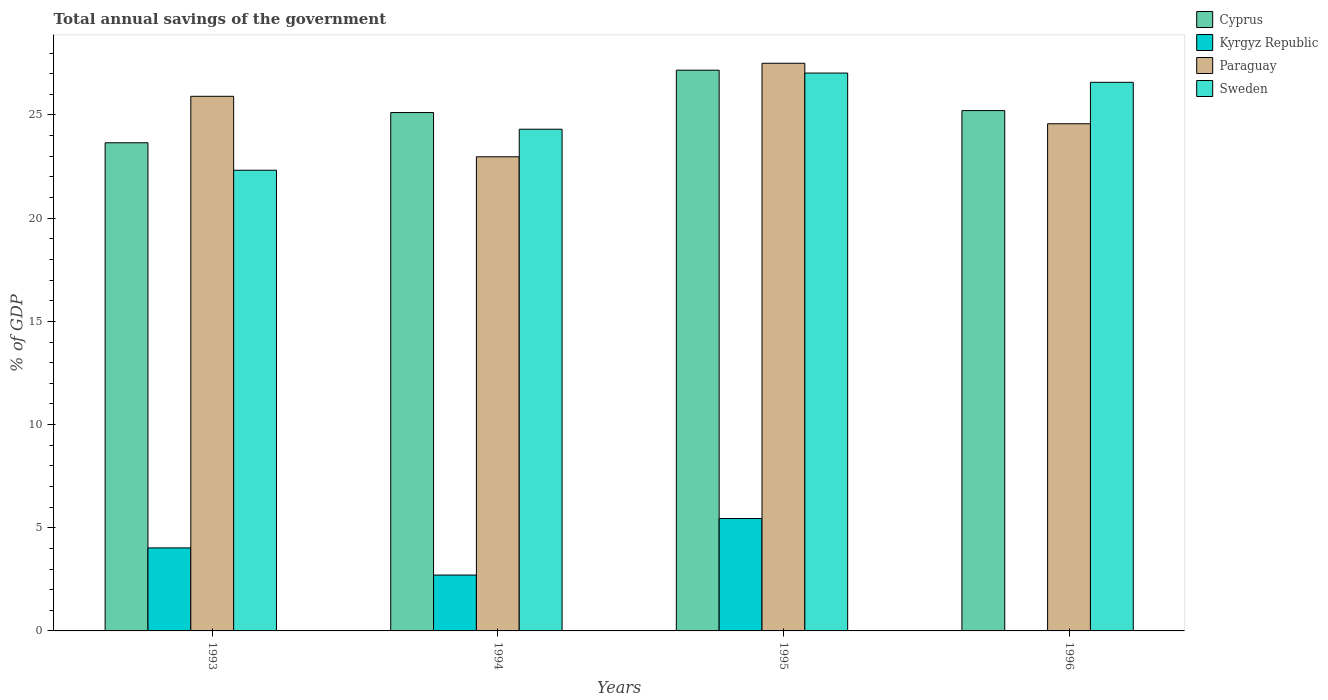How many groups of bars are there?
Provide a short and direct response. 4. Are the number of bars on each tick of the X-axis equal?
Ensure brevity in your answer.  No. In how many cases, is the number of bars for a given year not equal to the number of legend labels?
Your answer should be very brief. 1. What is the total annual savings of the government in Sweden in 1996?
Make the answer very short. 26.58. Across all years, what is the maximum total annual savings of the government in Sweden?
Your response must be concise. 27.03. Across all years, what is the minimum total annual savings of the government in Sweden?
Give a very brief answer. 22.32. In which year was the total annual savings of the government in Kyrgyz Republic maximum?
Provide a succinct answer. 1995. What is the total total annual savings of the government in Sweden in the graph?
Provide a succinct answer. 100.25. What is the difference between the total annual savings of the government in Paraguay in 1993 and that in 1995?
Provide a short and direct response. -1.6. What is the difference between the total annual savings of the government in Paraguay in 1996 and the total annual savings of the government in Sweden in 1994?
Keep it short and to the point. 0.26. What is the average total annual savings of the government in Sweden per year?
Provide a succinct answer. 25.06. In the year 1993, what is the difference between the total annual savings of the government in Kyrgyz Republic and total annual savings of the government in Sweden?
Your response must be concise. -18.3. In how many years, is the total annual savings of the government in Sweden greater than 14 %?
Ensure brevity in your answer.  4. What is the ratio of the total annual savings of the government in Sweden in 1994 to that in 1996?
Ensure brevity in your answer.  0.91. Is the total annual savings of the government in Kyrgyz Republic in 1993 less than that in 1994?
Provide a short and direct response. No. What is the difference between the highest and the second highest total annual savings of the government in Paraguay?
Your answer should be compact. 1.6. What is the difference between the highest and the lowest total annual savings of the government in Kyrgyz Republic?
Ensure brevity in your answer.  5.45. In how many years, is the total annual savings of the government in Cyprus greater than the average total annual savings of the government in Cyprus taken over all years?
Make the answer very short. 1. Is it the case that in every year, the sum of the total annual savings of the government in Paraguay and total annual savings of the government in Cyprus is greater than the sum of total annual savings of the government in Sweden and total annual savings of the government in Kyrgyz Republic?
Provide a short and direct response. No. Is it the case that in every year, the sum of the total annual savings of the government in Cyprus and total annual savings of the government in Paraguay is greater than the total annual savings of the government in Sweden?
Give a very brief answer. Yes. Are all the bars in the graph horizontal?
Offer a very short reply. No. What is the difference between two consecutive major ticks on the Y-axis?
Keep it short and to the point. 5. Does the graph contain any zero values?
Your answer should be very brief. Yes. Does the graph contain grids?
Provide a succinct answer. No. How many legend labels are there?
Give a very brief answer. 4. How are the legend labels stacked?
Ensure brevity in your answer.  Vertical. What is the title of the graph?
Give a very brief answer. Total annual savings of the government. Does "Portugal" appear as one of the legend labels in the graph?
Your answer should be very brief. No. What is the label or title of the X-axis?
Offer a terse response. Years. What is the label or title of the Y-axis?
Offer a very short reply. % of GDP. What is the % of GDP in Cyprus in 1993?
Your response must be concise. 23.65. What is the % of GDP in Kyrgyz Republic in 1993?
Your response must be concise. 4.02. What is the % of GDP in Paraguay in 1993?
Offer a terse response. 25.91. What is the % of GDP in Sweden in 1993?
Offer a terse response. 22.32. What is the % of GDP in Cyprus in 1994?
Your answer should be compact. 25.12. What is the % of GDP in Kyrgyz Republic in 1994?
Provide a short and direct response. 2.71. What is the % of GDP of Paraguay in 1994?
Provide a succinct answer. 22.97. What is the % of GDP in Sweden in 1994?
Offer a very short reply. 24.31. What is the % of GDP in Cyprus in 1995?
Give a very brief answer. 27.17. What is the % of GDP in Kyrgyz Republic in 1995?
Offer a terse response. 5.45. What is the % of GDP of Paraguay in 1995?
Keep it short and to the point. 27.51. What is the % of GDP in Sweden in 1995?
Your answer should be very brief. 27.03. What is the % of GDP in Cyprus in 1996?
Your answer should be very brief. 25.21. What is the % of GDP in Paraguay in 1996?
Provide a succinct answer. 24.58. What is the % of GDP in Sweden in 1996?
Your answer should be very brief. 26.58. Across all years, what is the maximum % of GDP in Cyprus?
Offer a terse response. 27.17. Across all years, what is the maximum % of GDP of Kyrgyz Republic?
Your answer should be compact. 5.45. Across all years, what is the maximum % of GDP of Paraguay?
Your answer should be compact. 27.51. Across all years, what is the maximum % of GDP of Sweden?
Provide a short and direct response. 27.03. Across all years, what is the minimum % of GDP of Cyprus?
Provide a short and direct response. 23.65. Across all years, what is the minimum % of GDP of Kyrgyz Republic?
Provide a short and direct response. 0. Across all years, what is the minimum % of GDP in Paraguay?
Keep it short and to the point. 22.97. Across all years, what is the minimum % of GDP of Sweden?
Give a very brief answer. 22.32. What is the total % of GDP of Cyprus in the graph?
Offer a terse response. 101.16. What is the total % of GDP of Kyrgyz Republic in the graph?
Ensure brevity in your answer.  12.18. What is the total % of GDP in Paraguay in the graph?
Offer a very short reply. 100.96. What is the total % of GDP of Sweden in the graph?
Your answer should be very brief. 100.25. What is the difference between the % of GDP of Cyprus in 1993 and that in 1994?
Provide a succinct answer. -1.46. What is the difference between the % of GDP in Kyrgyz Republic in 1993 and that in 1994?
Your response must be concise. 1.32. What is the difference between the % of GDP of Paraguay in 1993 and that in 1994?
Offer a very short reply. 2.93. What is the difference between the % of GDP of Sweden in 1993 and that in 1994?
Ensure brevity in your answer.  -1.99. What is the difference between the % of GDP of Cyprus in 1993 and that in 1995?
Give a very brief answer. -3.52. What is the difference between the % of GDP in Kyrgyz Republic in 1993 and that in 1995?
Give a very brief answer. -1.43. What is the difference between the % of GDP of Paraguay in 1993 and that in 1995?
Provide a short and direct response. -1.6. What is the difference between the % of GDP of Sweden in 1993 and that in 1995?
Offer a terse response. -4.71. What is the difference between the % of GDP of Cyprus in 1993 and that in 1996?
Your answer should be very brief. -1.56. What is the difference between the % of GDP of Paraguay in 1993 and that in 1996?
Your response must be concise. 1.33. What is the difference between the % of GDP of Sweden in 1993 and that in 1996?
Ensure brevity in your answer.  -4.26. What is the difference between the % of GDP of Cyprus in 1994 and that in 1995?
Provide a short and direct response. -2.05. What is the difference between the % of GDP in Kyrgyz Republic in 1994 and that in 1995?
Keep it short and to the point. -2.74. What is the difference between the % of GDP in Paraguay in 1994 and that in 1995?
Provide a short and direct response. -4.53. What is the difference between the % of GDP of Sweden in 1994 and that in 1995?
Provide a succinct answer. -2.72. What is the difference between the % of GDP of Cyprus in 1994 and that in 1996?
Provide a short and direct response. -0.09. What is the difference between the % of GDP of Paraguay in 1994 and that in 1996?
Keep it short and to the point. -1.6. What is the difference between the % of GDP of Sweden in 1994 and that in 1996?
Make the answer very short. -2.27. What is the difference between the % of GDP in Cyprus in 1995 and that in 1996?
Ensure brevity in your answer.  1.96. What is the difference between the % of GDP in Paraguay in 1995 and that in 1996?
Make the answer very short. 2.93. What is the difference between the % of GDP in Sweden in 1995 and that in 1996?
Your answer should be very brief. 0.45. What is the difference between the % of GDP in Cyprus in 1993 and the % of GDP in Kyrgyz Republic in 1994?
Offer a very short reply. 20.95. What is the difference between the % of GDP in Cyprus in 1993 and the % of GDP in Paraguay in 1994?
Your response must be concise. 0.68. What is the difference between the % of GDP of Cyprus in 1993 and the % of GDP of Sweden in 1994?
Give a very brief answer. -0.66. What is the difference between the % of GDP in Kyrgyz Republic in 1993 and the % of GDP in Paraguay in 1994?
Your response must be concise. -18.95. What is the difference between the % of GDP of Kyrgyz Republic in 1993 and the % of GDP of Sweden in 1994?
Ensure brevity in your answer.  -20.29. What is the difference between the % of GDP of Paraguay in 1993 and the % of GDP of Sweden in 1994?
Ensure brevity in your answer.  1.6. What is the difference between the % of GDP of Cyprus in 1993 and the % of GDP of Kyrgyz Republic in 1995?
Ensure brevity in your answer.  18.21. What is the difference between the % of GDP in Cyprus in 1993 and the % of GDP in Paraguay in 1995?
Keep it short and to the point. -3.85. What is the difference between the % of GDP in Cyprus in 1993 and the % of GDP in Sweden in 1995?
Offer a terse response. -3.38. What is the difference between the % of GDP of Kyrgyz Republic in 1993 and the % of GDP of Paraguay in 1995?
Ensure brevity in your answer.  -23.48. What is the difference between the % of GDP in Kyrgyz Republic in 1993 and the % of GDP in Sweden in 1995?
Make the answer very short. -23.01. What is the difference between the % of GDP in Paraguay in 1993 and the % of GDP in Sweden in 1995?
Give a very brief answer. -1.13. What is the difference between the % of GDP in Cyprus in 1993 and the % of GDP in Paraguay in 1996?
Offer a terse response. -0.92. What is the difference between the % of GDP in Cyprus in 1993 and the % of GDP in Sweden in 1996?
Provide a succinct answer. -2.93. What is the difference between the % of GDP of Kyrgyz Republic in 1993 and the % of GDP of Paraguay in 1996?
Offer a terse response. -20.55. What is the difference between the % of GDP in Kyrgyz Republic in 1993 and the % of GDP in Sweden in 1996?
Your answer should be compact. -22.56. What is the difference between the % of GDP of Paraguay in 1993 and the % of GDP of Sweden in 1996?
Your answer should be compact. -0.68. What is the difference between the % of GDP of Cyprus in 1994 and the % of GDP of Kyrgyz Republic in 1995?
Provide a short and direct response. 19.67. What is the difference between the % of GDP of Cyprus in 1994 and the % of GDP of Paraguay in 1995?
Ensure brevity in your answer.  -2.39. What is the difference between the % of GDP in Cyprus in 1994 and the % of GDP in Sweden in 1995?
Offer a very short reply. -1.91. What is the difference between the % of GDP in Kyrgyz Republic in 1994 and the % of GDP in Paraguay in 1995?
Ensure brevity in your answer.  -24.8. What is the difference between the % of GDP in Kyrgyz Republic in 1994 and the % of GDP in Sweden in 1995?
Offer a very short reply. -24.33. What is the difference between the % of GDP in Paraguay in 1994 and the % of GDP in Sweden in 1995?
Offer a very short reply. -4.06. What is the difference between the % of GDP of Cyprus in 1994 and the % of GDP of Paraguay in 1996?
Provide a succinct answer. 0.54. What is the difference between the % of GDP in Cyprus in 1994 and the % of GDP in Sweden in 1996?
Give a very brief answer. -1.46. What is the difference between the % of GDP of Kyrgyz Republic in 1994 and the % of GDP of Paraguay in 1996?
Offer a terse response. -21.87. What is the difference between the % of GDP of Kyrgyz Republic in 1994 and the % of GDP of Sweden in 1996?
Provide a succinct answer. -23.88. What is the difference between the % of GDP of Paraguay in 1994 and the % of GDP of Sweden in 1996?
Provide a short and direct response. -3.61. What is the difference between the % of GDP of Cyprus in 1995 and the % of GDP of Paraguay in 1996?
Your response must be concise. 2.6. What is the difference between the % of GDP of Cyprus in 1995 and the % of GDP of Sweden in 1996?
Ensure brevity in your answer.  0.59. What is the difference between the % of GDP of Kyrgyz Republic in 1995 and the % of GDP of Paraguay in 1996?
Make the answer very short. -19.13. What is the difference between the % of GDP in Kyrgyz Republic in 1995 and the % of GDP in Sweden in 1996?
Your answer should be compact. -21.14. What is the difference between the % of GDP in Paraguay in 1995 and the % of GDP in Sweden in 1996?
Make the answer very short. 0.92. What is the average % of GDP in Cyprus per year?
Your answer should be compact. 25.29. What is the average % of GDP in Kyrgyz Republic per year?
Your answer should be very brief. 3.04. What is the average % of GDP in Paraguay per year?
Make the answer very short. 25.24. What is the average % of GDP of Sweden per year?
Your answer should be compact. 25.06. In the year 1993, what is the difference between the % of GDP of Cyprus and % of GDP of Kyrgyz Republic?
Your answer should be very brief. 19.63. In the year 1993, what is the difference between the % of GDP in Cyprus and % of GDP in Paraguay?
Provide a short and direct response. -2.25. In the year 1993, what is the difference between the % of GDP in Cyprus and % of GDP in Sweden?
Offer a very short reply. 1.33. In the year 1993, what is the difference between the % of GDP in Kyrgyz Republic and % of GDP in Paraguay?
Your answer should be compact. -21.88. In the year 1993, what is the difference between the % of GDP in Kyrgyz Republic and % of GDP in Sweden?
Your response must be concise. -18.3. In the year 1993, what is the difference between the % of GDP of Paraguay and % of GDP of Sweden?
Offer a very short reply. 3.58. In the year 1994, what is the difference between the % of GDP in Cyprus and % of GDP in Kyrgyz Republic?
Keep it short and to the point. 22.41. In the year 1994, what is the difference between the % of GDP of Cyprus and % of GDP of Paraguay?
Your answer should be very brief. 2.14. In the year 1994, what is the difference between the % of GDP in Cyprus and % of GDP in Sweden?
Provide a succinct answer. 0.81. In the year 1994, what is the difference between the % of GDP of Kyrgyz Republic and % of GDP of Paraguay?
Keep it short and to the point. -20.27. In the year 1994, what is the difference between the % of GDP of Kyrgyz Republic and % of GDP of Sweden?
Ensure brevity in your answer.  -21.6. In the year 1994, what is the difference between the % of GDP in Paraguay and % of GDP in Sweden?
Offer a very short reply. -1.34. In the year 1995, what is the difference between the % of GDP of Cyprus and % of GDP of Kyrgyz Republic?
Provide a short and direct response. 21.72. In the year 1995, what is the difference between the % of GDP in Cyprus and % of GDP in Paraguay?
Your response must be concise. -0.34. In the year 1995, what is the difference between the % of GDP in Cyprus and % of GDP in Sweden?
Provide a short and direct response. 0.14. In the year 1995, what is the difference between the % of GDP of Kyrgyz Republic and % of GDP of Paraguay?
Ensure brevity in your answer.  -22.06. In the year 1995, what is the difference between the % of GDP in Kyrgyz Republic and % of GDP in Sweden?
Keep it short and to the point. -21.58. In the year 1995, what is the difference between the % of GDP of Paraguay and % of GDP of Sweden?
Your answer should be very brief. 0.47. In the year 1996, what is the difference between the % of GDP in Cyprus and % of GDP in Paraguay?
Make the answer very short. 0.64. In the year 1996, what is the difference between the % of GDP of Cyprus and % of GDP of Sweden?
Offer a terse response. -1.37. In the year 1996, what is the difference between the % of GDP of Paraguay and % of GDP of Sweden?
Your answer should be very brief. -2.01. What is the ratio of the % of GDP in Cyprus in 1993 to that in 1994?
Give a very brief answer. 0.94. What is the ratio of the % of GDP in Kyrgyz Republic in 1993 to that in 1994?
Your response must be concise. 1.49. What is the ratio of the % of GDP in Paraguay in 1993 to that in 1994?
Ensure brevity in your answer.  1.13. What is the ratio of the % of GDP of Sweden in 1993 to that in 1994?
Ensure brevity in your answer.  0.92. What is the ratio of the % of GDP in Cyprus in 1993 to that in 1995?
Keep it short and to the point. 0.87. What is the ratio of the % of GDP in Kyrgyz Republic in 1993 to that in 1995?
Your response must be concise. 0.74. What is the ratio of the % of GDP of Paraguay in 1993 to that in 1995?
Offer a terse response. 0.94. What is the ratio of the % of GDP of Sweden in 1993 to that in 1995?
Your response must be concise. 0.83. What is the ratio of the % of GDP of Cyprus in 1993 to that in 1996?
Make the answer very short. 0.94. What is the ratio of the % of GDP of Paraguay in 1993 to that in 1996?
Provide a short and direct response. 1.05. What is the ratio of the % of GDP in Sweden in 1993 to that in 1996?
Your answer should be very brief. 0.84. What is the ratio of the % of GDP of Cyprus in 1994 to that in 1995?
Make the answer very short. 0.92. What is the ratio of the % of GDP of Kyrgyz Republic in 1994 to that in 1995?
Provide a succinct answer. 0.5. What is the ratio of the % of GDP in Paraguay in 1994 to that in 1995?
Your answer should be very brief. 0.84. What is the ratio of the % of GDP of Sweden in 1994 to that in 1995?
Keep it short and to the point. 0.9. What is the ratio of the % of GDP of Cyprus in 1994 to that in 1996?
Your answer should be compact. 1. What is the ratio of the % of GDP of Paraguay in 1994 to that in 1996?
Provide a short and direct response. 0.93. What is the ratio of the % of GDP in Sweden in 1994 to that in 1996?
Keep it short and to the point. 0.91. What is the ratio of the % of GDP of Cyprus in 1995 to that in 1996?
Give a very brief answer. 1.08. What is the ratio of the % of GDP of Paraguay in 1995 to that in 1996?
Offer a very short reply. 1.12. What is the ratio of the % of GDP of Sweden in 1995 to that in 1996?
Provide a short and direct response. 1.02. What is the difference between the highest and the second highest % of GDP in Cyprus?
Your answer should be very brief. 1.96. What is the difference between the highest and the second highest % of GDP of Kyrgyz Republic?
Provide a succinct answer. 1.43. What is the difference between the highest and the second highest % of GDP of Paraguay?
Keep it short and to the point. 1.6. What is the difference between the highest and the second highest % of GDP of Sweden?
Your response must be concise. 0.45. What is the difference between the highest and the lowest % of GDP in Cyprus?
Your response must be concise. 3.52. What is the difference between the highest and the lowest % of GDP of Kyrgyz Republic?
Offer a terse response. 5.45. What is the difference between the highest and the lowest % of GDP in Paraguay?
Make the answer very short. 4.53. What is the difference between the highest and the lowest % of GDP in Sweden?
Your answer should be very brief. 4.71. 